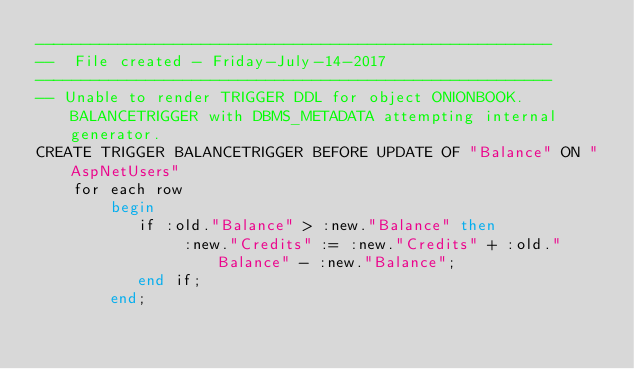Convert code to text. <code><loc_0><loc_0><loc_500><loc_500><_SQL_>--------------------------------------------------------
--  File created - Friday-July-14-2017   
--------------------------------------------------------
-- Unable to render TRIGGER DDL for object ONIONBOOK.BALANCETRIGGER with DBMS_METADATA attempting internal generator.
CREATE TRIGGER BALANCETRIGGER BEFORE UPDATE OF "Balance" ON "AspNetUsers" 
    for each row
        begin
           if :old."Balance" > :new."Balance" then
                :new."Credits" := :new."Credits" + :old."Balance" - :new."Balance";
           end if;
        end;
</code> 